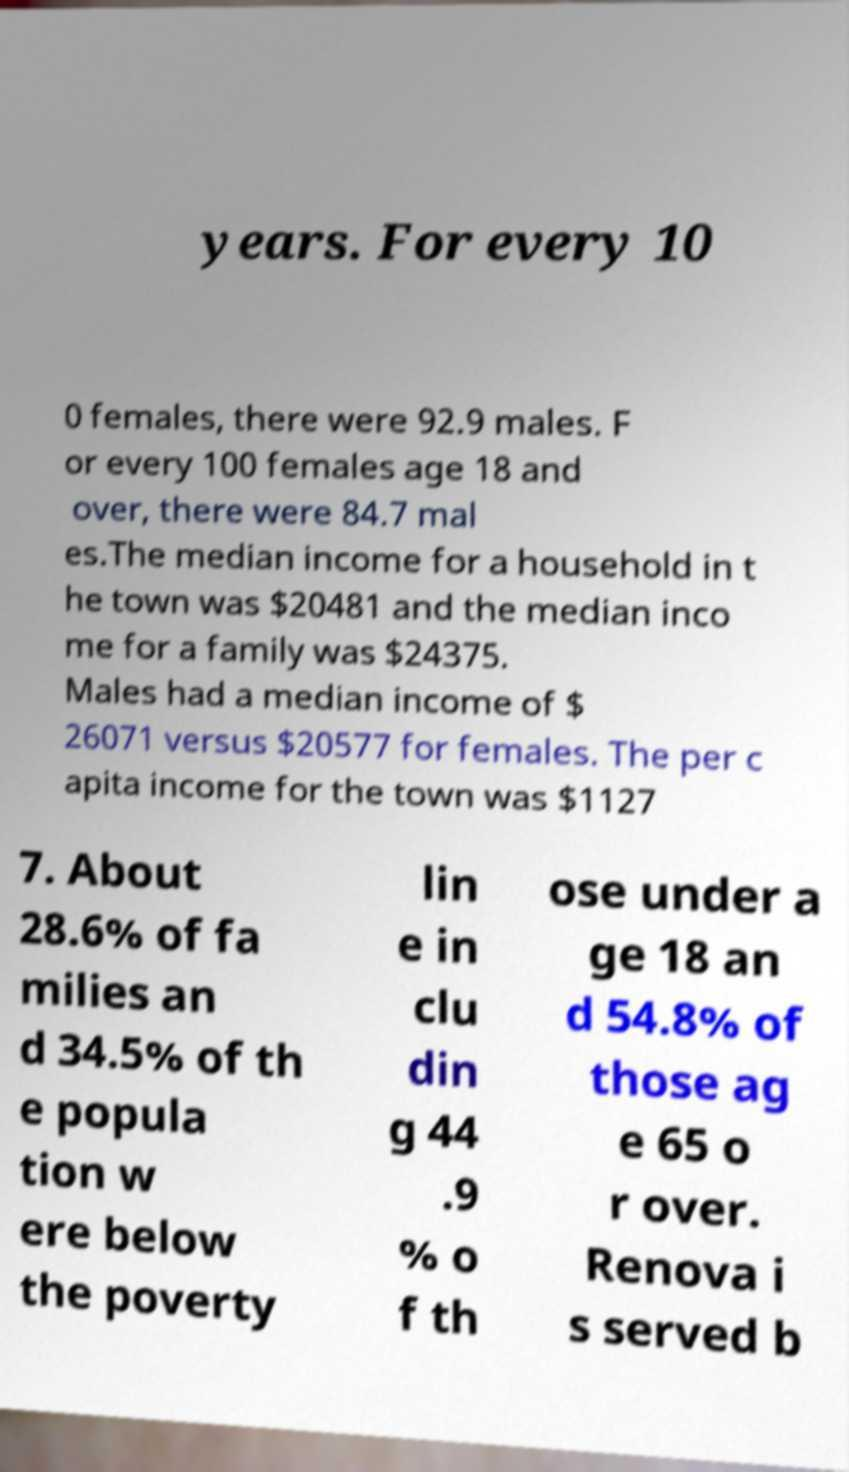Can you accurately transcribe the text from the provided image for me? years. For every 10 0 females, there were 92.9 males. F or every 100 females age 18 and over, there were 84.7 mal es.The median income for a household in t he town was $20481 and the median inco me for a family was $24375. Males had a median income of $ 26071 versus $20577 for females. The per c apita income for the town was $1127 7. About 28.6% of fa milies an d 34.5% of th e popula tion w ere below the poverty lin e in clu din g 44 .9 % o f th ose under a ge 18 an d 54.8% of those ag e 65 o r over. Renova i s served b 